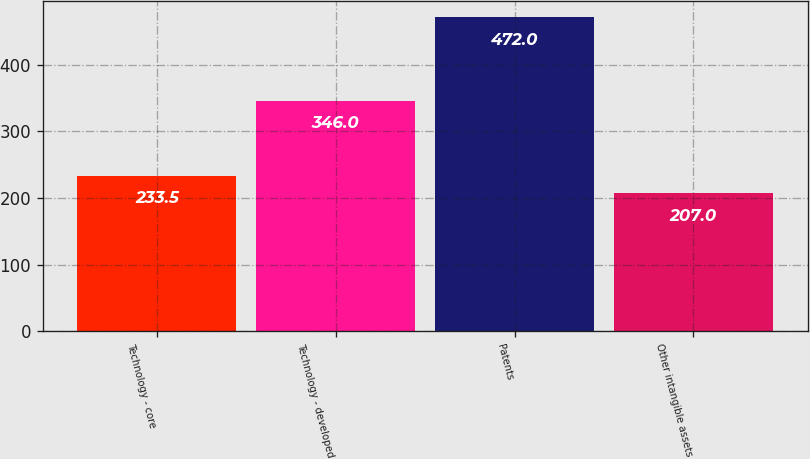Convert chart to OTSL. <chart><loc_0><loc_0><loc_500><loc_500><bar_chart><fcel>Technology - core<fcel>Technology - developed<fcel>Patents<fcel>Other intangible assets<nl><fcel>233.5<fcel>346<fcel>472<fcel>207<nl></chart> 